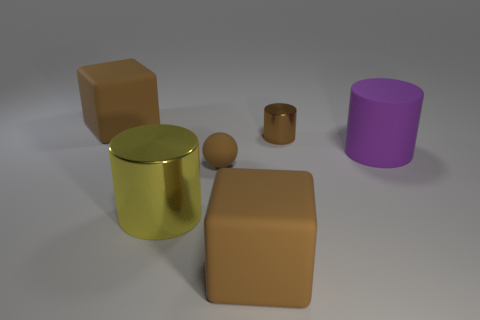What is the large thing that is to the right of the small rubber ball and left of the big purple matte thing made of?
Ensure brevity in your answer.  Rubber. There is a rubber block in front of the big matte object that is on the left side of the large block that is in front of the small brown shiny cylinder; what color is it?
Offer a terse response. Brown. How many blue things are either tiny balls or big cubes?
Provide a succinct answer. 0. How many other objects are there of the same size as the brown sphere?
Your answer should be compact. 1. How many yellow metal objects are there?
Your answer should be very brief. 1. Are there any other things that have the same shape as the small brown rubber thing?
Give a very brief answer. No. Do the cylinder that is right of the tiny brown metal thing and the cylinder that is in front of the large purple cylinder have the same material?
Your response must be concise. No. What is the big purple cylinder made of?
Make the answer very short. Rubber. How many other objects have the same material as the big purple object?
Keep it short and to the point. 3. How many matte objects are either large yellow cylinders or brown balls?
Offer a terse response. 1. 